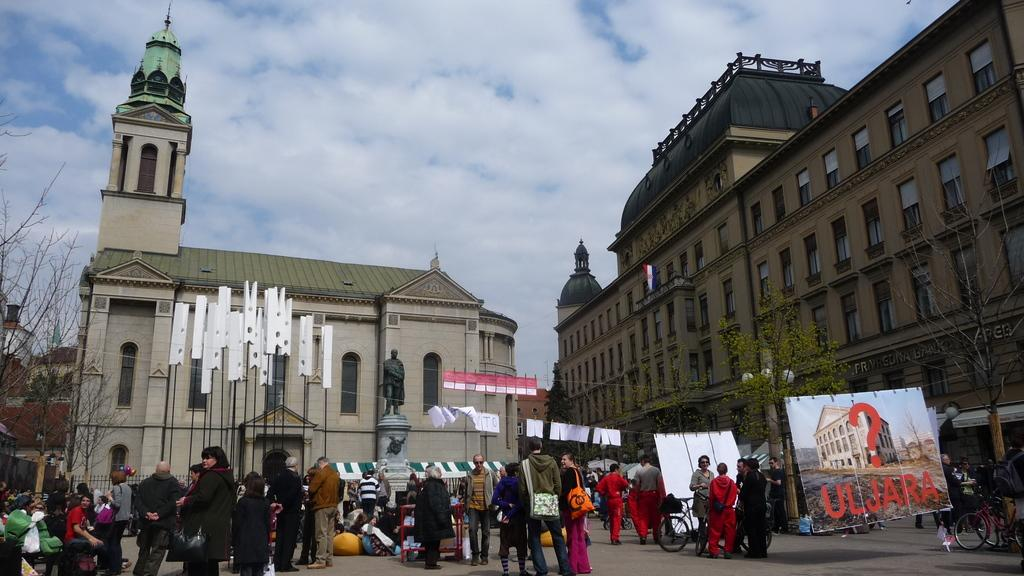How many people can be seen in the image? There are people in the image, but the exact number is not specified. What is one of the main features of the image? There is a road in the image. What type of decorations are present in the image? There are banners in the image. What kind of structure can be seen in the image? There is a statue in the image. What type of vegetation is visible in the image? There are trees in the image. What mode of transportation is present in the image? There is a bicycle in the image. What type of infrastructure is present in the image? There are poles in the image. What type of illumination is present in the image? There are lights in the image. What type of man-made structures are visible in the image? There are buildings in the image. What can be seen in the background of the image? There is a sky with clouds visible in the background of the image. What subject is being taught in the image? There is no indication of any teaching or educational activity in the image. How does the heat affect the people in the image? The image does not provide any information about the temperature or weather conditions, so it is impossible to determine how heat might affect the people in the image. 